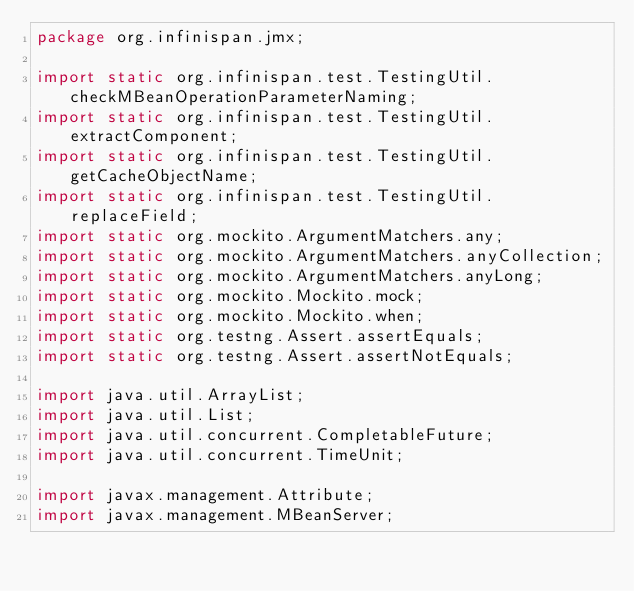<code> <loc_0><loc_0><loc_500><loc_500><_Java_>package org.infinispan.jmx;

import static org.infinispan.test.TestingUtil.checkMBeanOperationParameterNaming;
import static org.infinispan.test.TestingUtil.extractComponent;
import static org.infinispan.test.TestingUtil.getCacheObjectName;
import static org.infinispan.test.TestingUtil.replaceField;
import static org.mockito.ArgumentMatchers.any;
import static org.mockito.ArgumentMatchers.anyCollection;
import static org.mockito.ArgumentMatchers.anyLong;
import static org.mockito.Mockito.mock;
import static org.mockito.Mockito.when;
import static org.testng.Assert.assertEquals;
import static org.testng.Assert.assertNotEquals;

import java.util.ArrayList;
import java.util.List;
import java.util.concurrent.CompletableFuture;
import java.util.concurrent.TimeUnit;

import javax.management.Attribute;
import javax.management.MBeanServer;</code> 